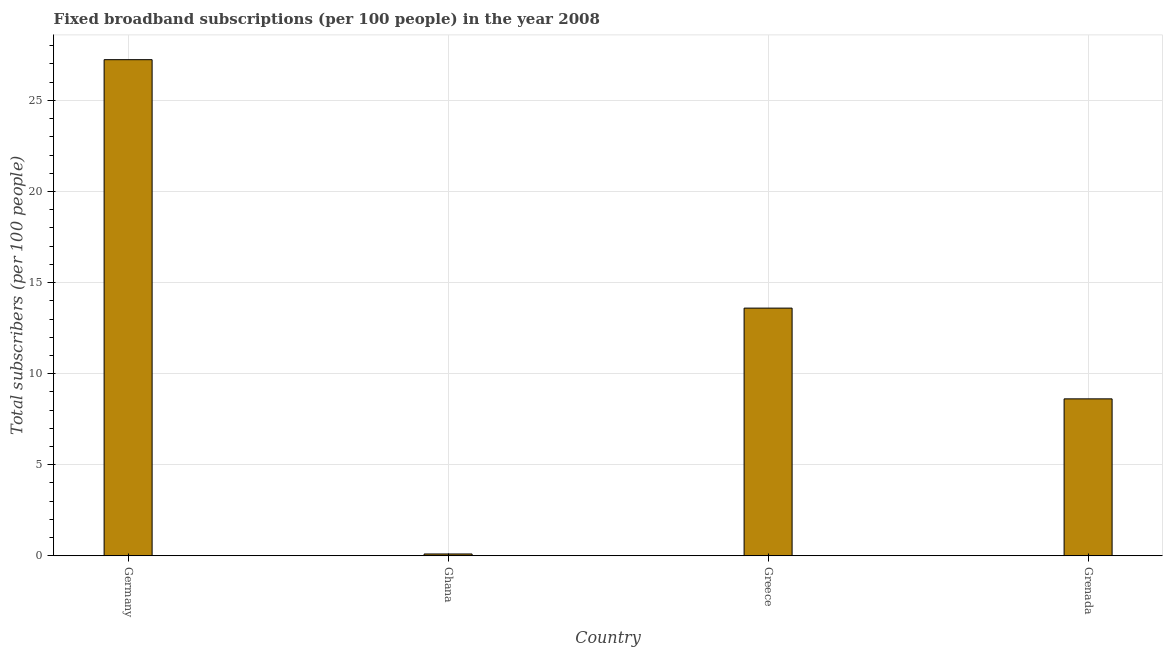Does the graph contain any zero values?
Offer a very short reply. No. Does the graph contain grids?
Your answer should be compact. Yes. What is the title of the graph?
Provide a short and direct response. Fixed broadband subscriptions (per 100 people) in the year 2008. What is the label or title of the Y-axis?
Provide a short and direct response. Total subscribers (per 100 people). What is the total number of fixed broadband subscriptions in Ghana?
Ensure brevity in your answer.  0.1. Across all countries, what is the maximum total number of fixed broadband subscriptions?
Offer a terse response. 27.24. Across all countries, what is the minimum total number of fixed broadband subscriptions?
Your response must be concise. 0.1. What is the sum of the total number of fixed broadband subscriptions?
Offer a very short reply. 49.55. What is the difference between the total number of fixed broadband subscriptions in Germany and Greece?
Offer a very short reply. 13.64. What is the average total number of fixed broadband subscriptions per country?
Ensure brevity in your answer.  12.39. What is the median total number of fixed broadband subscriptions?
Your answer should be compact. 11.11. What is the ratio of the total number of fixed broadband subscriptions in Germany to that in Grenada?
Give a very brief answer. 3.16. Is the difference between the total number of fixed broadband subscriptions in Ghana and Grenada greater than the difference between any two countries?
Provide a short and direct response. No. What is the difference between the highest and the second highest total number of fixed broadband subscriptions?
Provide a succinct answer. 13.64. Is the sum of the total number of fixed broadband subscriptions in Germany and Grenada greater than the maximum total number of fixed broadband subscriptions across all countries?
Your response must be concise. Yes. What is the difference between the highest and the lowest total number of fixed broadband subscriptions?
Your answer should be compact. 27.14. In how many countries, is the total number of fixed broadband subscriptions greater than the average total number of fixed broadband subscriptions taken over all countries?
Make the answer very short. 2. How many bars are there?
Make the answer very short. 4. Are all the bars in the graph horizontal?
Provide a short and direct response. No. Are the values on the major ticks of Y-axis written in scientific E-notation?
Keep it short and to the point. No. What is the Total subscribers (per 100 people) of Germany?
Offer a very short reply. 27.24. What is the Total subscribers (per 100 people) of Ghana?
Make the answer very short. 0.1. What is the Total subscribers (per 100 people) of Greece?
Offer a terse response. 13.6. What is the Total subscribers (per 100 people) in Grenada?
Make the answer very short. 8.62. What is the difference between the Total subscribers (per 100 people) in Germany and Ghana?
Make the answer very short. 27.14. What is the difference between the Total subscribers (per 100 people) in Germany and Greece?
Ensure brevity in your answer.  13.64. What is the difference between the Total subscribers (per 100 people) in Germany and Grenada?
Ensure brevity in your answer.  18.62. What is the difference between the Total subscribers (per 100 people) in Ghana and Greece?
Provide a succinct answer. -13.5. What is the difference between the Total subscribers (per 100 people) in Ghana and Grenada?
Provide a short and direct response. -8.52. What is the difference between the Total subscribers (per 100 people) in Greece and Grenada?
Provide a short and direct response. 4.98. What is the ratio of the Total subscribers (per 100 people) in Germany to that in Ghana?
Your answer should be compact. 273.91. What is the ratio of the Total subscribers (per 100 people) in Germany to that in Greece?
Ensure brevity in your answer.  2. What is the ratio of the Total subscribers (per 100 people) in Germany to that in Grenada?
Your answer should be very brief. 3.16. What is the ratio of the Total subscribers (per 100 people) in Ghana to that in Greece?
Offer a very short reply. 0.01. What is the ratio of the Total subscribers (per 100 people) in Ghana to that in Grenada?
Give a very brief answer. 0.01. What is the ratio of the Total subscribers (per 100 people) in Greece to that in Grenada?
Provide a succinct answer. 1.58. 